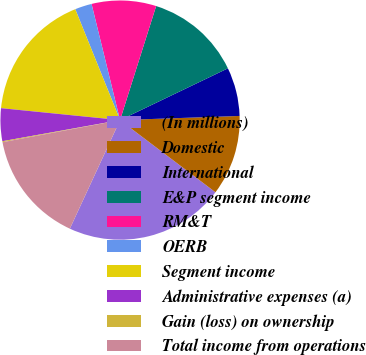Convert chart to OTSL. <chart><loc_0><loc_0><loc_500><loc_500><pie_chart><fcel>(In millions)<fcel>Domestic<fcel>International<fcel>E&P segment income<fcel>RM&T<fcel>OERB<fcel>Segment income<fcel>Administrative expenses (a)<fcel>Gain (loss) on ownership<fcel>Total income from operations<nl><fcel>21.59%<fcel>10.86%<fcel>6.57%<fcel>13.0%<fcel>8.71%<fcel>2.28%<fcel>17.3%<fcel>4.42%<fcel>0.13%<fcel>15.15%<nl></chart> 